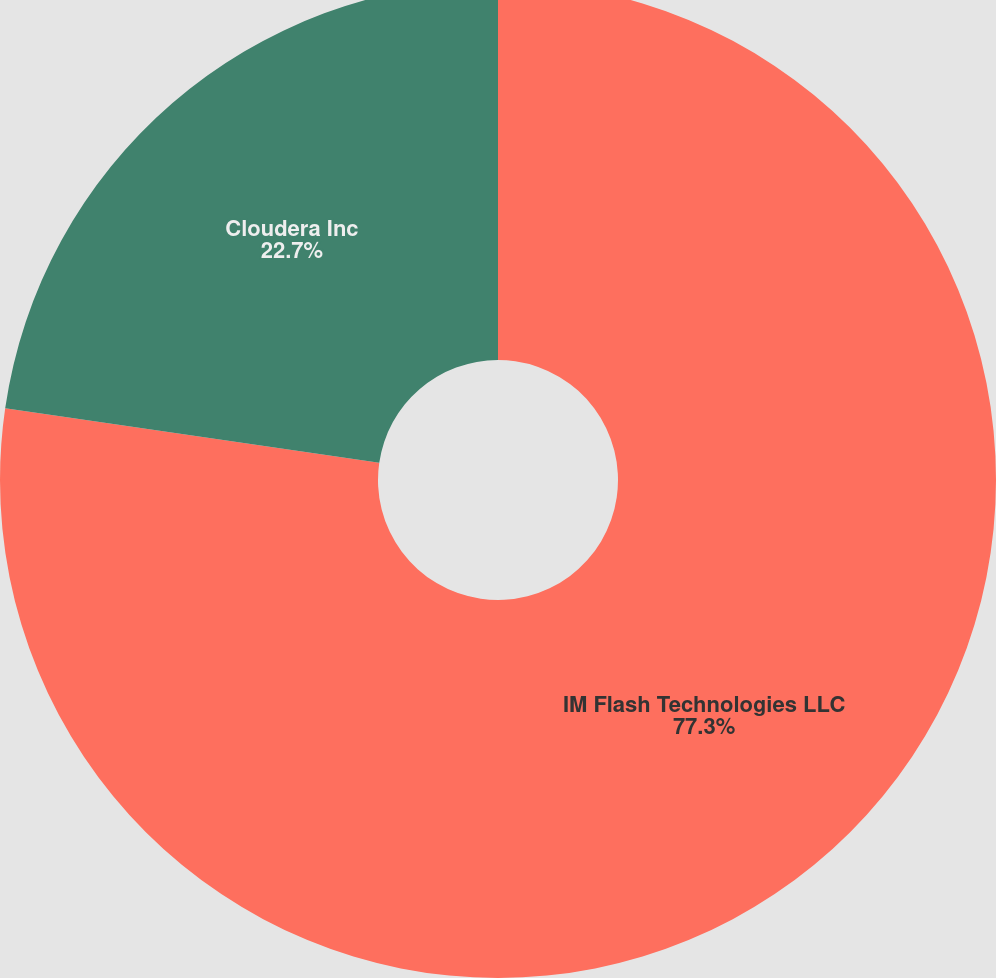Convert chart. <chart><loc_0><loc_0><loc_500><loc_500><pie_chart><fcel>IM Flash Technologies LLC<fcel>Cloudera Inc<nl><fcel>77.3%<fcel>22.7%<nl></chart> 